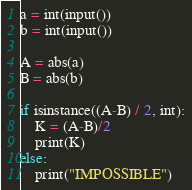<code> <loc_0><loc_0><loc_500><loc_500><_Python_>a = int(input())
b = int(input())

A = abs(a)
B = abs(b)

if isinstance((A-B) / 2, int):
    K = (A-B)/2
    print(K)
else:
    print("IMPOSSIBLE")</code> 